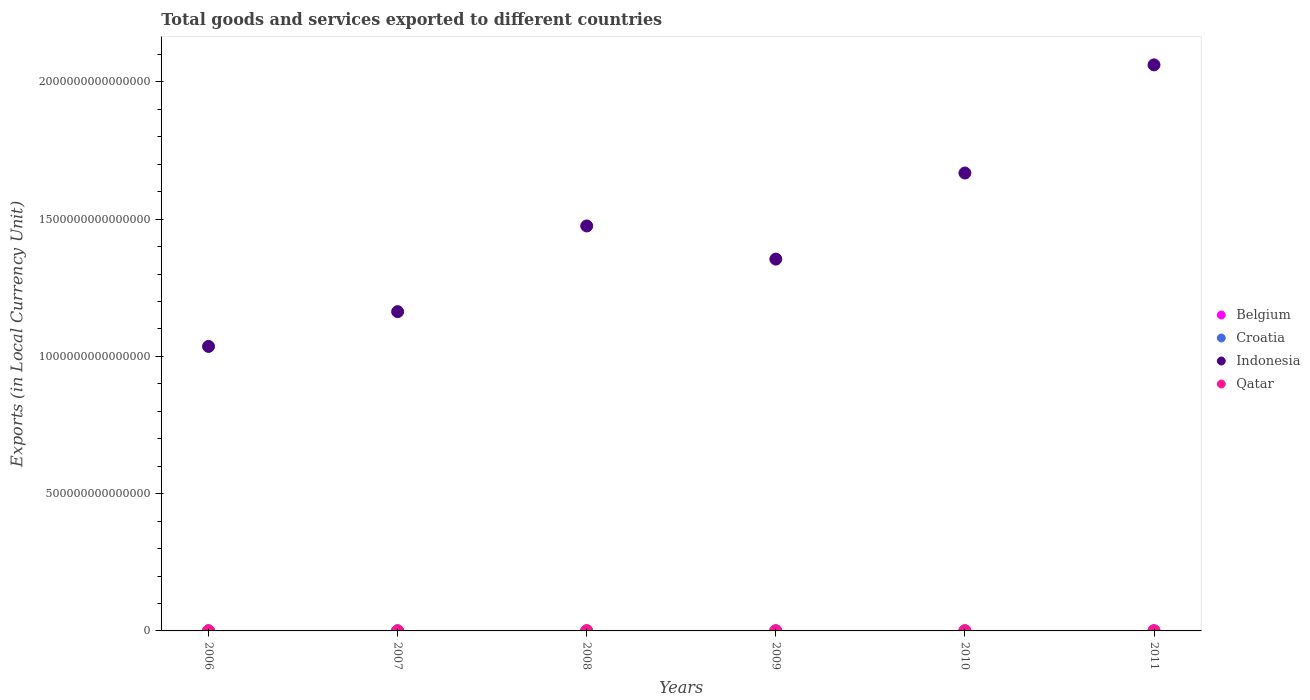What is the Amount of goods and services exports in Belgium in 2008?
Offer a terse response. 2.82e+11. Across all years, what is the maximum Amount of goods and services exports in Indonesia?
Offer a very short reply. 2.06e+15. Across all years, what is the minimum Amount of goods and services exports in Croatia?
Give a very brief answer. 1.14e+11. What is the total Amount of goods and services exports in Croatia in the graph?
Give a very brief answer. 7.49e+11. What is the difference between the Amount of goods and services exports in Belgium in 2008 and that in 2011?
Keep it short and to the point. -2.73e+1. What is the difference between the Amount of goods and services exports in Croatia in 2011 and the Amount of goods and services exports in Indonesia in 2007?
Give a very brief answer. -1.16e+15. What is the average Amount of goods and services exports in Belgium per year?
Offer a very short reply. 2.71e+11. In the year 2011, what is the difference between the Amount of goods and services exports in Indonesia and Amount of goods and services exports in Belgium?
Provide a succinct answer. 2.06e+15. What is the ratio of the Amount of goods and services exports in Qatar in 2007 to that in 2011?
Your answer should be compact. 0.39. What is the difference between the highest and the second highest Amount of goods and services exports in Croatia?
Give a very brief answer. 6.04e+08. What is the difference between the highest and the lowest Amount of goods and services exports in Croatia?
Your answer should be compact. 2.01e+1. Is the sum of the Amount of goods and services exports in Indonesia in 2006 and 2011 greater than the maximum Amount of goods and services exports in Croatia across all years?
Make the answer very short. Yes. Is it the case that in every year, the sum of the Amount of goods and services exports in Croatia and Amount of goods and services exports in Qatar  is greater than the Amount of goods and services exports in Indonesia?
Provide a succinct answer. No. What is the difference between two consecutive major ticks on the Y-axis?
Provide a short and direct response. 5.00e+14. Are the values on the major ticks of Y-axis written in scientific E-notation?
Offer a terse response. No. Does the graph contain any zero values?
Provide a succinct answer. No. Does the graph contain grids?
Your answer should be compact. No. What is the title of the graph?
Offer a very short reply. Total goods and services exported to different countries. What is the label or title of the Y-axis?
Provide a succinct answer. Exports (in Local Currency Unit). What is the Exports (in Local Currency Unit) of Belgium in 2006?
Keep it short and to the point. 2.47e+11. What is the Exports (in Local Currency Unit) of Croatia in 2006?
Your answer should be very brief. 1.17e+11. What is the Exports (in Local Currency Unit) in Indonesia in 2006?
Provide a short and direct response. 1.04e+15. What is the Exports (in Local Currency Unit) in Qatar in 2006?
Give a very brief answer. 1.39e+11. What is the Exports (in Local Currency Unit) in Belgium in 2007?
Offer a terse response. 2.67e+11. What is the Exports (in Local Currency Unit) in Croatia in 2007?
Your response must be concise. 1.26e+11. What is the Exports (in Local Currency Unit) in Indonesia in 2007?
Offer a terse response. 1.16e+15. What is the Exports (in Local Currency Unit) of Qatar in 2007?
Keep it short and to the point. 1.75e+11. What is the Exports (in Local Currency Unit) of Belgium in 2008?
Make the answer very short. 2.82e+11. What is the Exports (in Local Currency Unit) of Croatia in 2008?
Your answer should be very brief. 1.34e+11. What is the Exports (in Local Currency Unit) of Indonesia in 2008?
Your answer should be compact. 1.48e+15. What is the Exports (in Local Currency Unit) in Qatar in 2008?
Give a very brief answer. 2.57e+11. What is the Exports (in Local Currency Unit) in Belgium in 2009?
Provide a succinct answer. 2.42e+11. What is the Exports (in Local Currency Unit) of Croatia in 2009?
Offer a terse response. 1.14e+11. What is the Exports (in Local Currency Unit) in Indonesia in 2009?
Your response must be concise. 1.35e+15. What is the Exports (in Local Currency Unit) of Qatar in 2009?
Provide a short and direct response. 1.82e+11. What is the Exports (in Local Currency Unit) of Belgium in 2010?
Ensure brevity in your answer.  2.79e+11. What is the Exports (in Local Currency Unit) in Croatia in 2010?
Ensure brevity in your answer.  1.24e+11. What is the Exports (in Local Currency Unit) in Indonesia in 2010?
Offer a terse response. 1.67e+15. What is the Exports (in Local Currency Unit) of Qatar in 2010?
Keep it short and to the point. 2.84e+11. What is the Exports (in Local Currency Unit) in Belgium in 2011?
Offer a very short reply. 3.09e+11. What is the Exports (in Local Currency Unit) of Croatia in 2011?
Make the answer very short. 1.34e+11. What is the Exports (in Local Currency Unit) of Indonesia in 2011?
Give a very brief answer. 2.06e+15. What is the Exports (in Local Currency Unit) of Qatar in 2011?
Provide a short and direct response. 4.43e+11. Across all years, what is the maximum Exports (in Local Currency Unit) of Belgium?
Your response must be concise. 3.09e+11. Across all years, what is the maximum Exports (in Local Currency Unit) of Croatia?
Ensure brevity in your answer.  1.34e+11. Across all years, what is the maximum Exports (in Local Currency Unit) of Indonesia?
Ensure brevity in your answer.  2.06e+15. Across all years, what is the maximum Exports (in Local Currency Unit) in Qatar?
Give a very brief answer. 4.43e+11. Across all years, what is the minimum Exports (in Local Currency Unit) in Belgium?
Make the answer very short. 2.42e+11. Across all years, what is the minimum Exports (in Local Currency Unit) in Croatia?
Your answer should be very brief. 1.14e+11. Across all years, what is the minimum Exports (in Local Currency Unit) in Indonesia?
Keep it short and to the point. 1.04e+15. Across all years, what is the minimum Exports (in Local Currency Unit) in Qatar?
Your answer should be compact. 1.39e+11. What is the total Exports (in Local Currency Unit) of Belgium in the graph?
Your answer should be compact. 1.63e+12. What is the total Exports (in Local Currency Unit) in Croatia in the graph?
Your answer should be compact. 7.49e+11. What is the total Exports (in Local Currency Unit) in Indonesia in the graph?
Your response must be concise. 8.76e+15. What is the total Exports (in Local Currency Unit) of Qatar in the graph?
Ensure brevity in your answer.  1.48e+12. What is the difference between the Exports (in Local Currency Unit) of Belgium in 2006 and that in 2007?
Your answer should be compact. -1.98e+1. What is the difference between the Exports (in Local Currency Unit) in Croatia in 2006 and that in 2007?
Your response must be concise. -8.92e+09. What is the difference between the Exports (in Local Currency Unit) of Indonesia in 2006 and that in 2007?
Your answer should be very brief. -1.27e+14. What is the difference between the Exports (in Local Currency Unit) of Qatar in 2006 and that in 2007?
Give a very brief answer. -3.57e+1. What is the difference between the Exports (in Local Currency Unit) of Belgium in 2006 and that in 2008?
Provide a succinct answer. -3.49e+1. What is the difference between the Exports (in Local Currency Unit) in Croatia in 2006 and that in 2008?
Your answer should be very brief. -1.70e+1. What is the difference between the Exports (in Local Currency Unit) of Indonesia in 2006 and that in 2008?
Offer a very short reply. -4.39e+14. What is the difference between the Exports (in Local Currency Unit) of Qatar in 2006 and that in 2008?
Keep it short and to the point. -1.18e+11. What is the difference between the Exports (in Local Currency Unit) of Belgium in 2006 and that in 2009?
Your response must be concise. 5.58e+09. What is the difference between the Exports (in Local Currency Unit) in Croatia in 2006 and that in 2009?
Keep it short and to the point. 2.52e+09. What is the difference between the Exports (in Local Currency Unit) of Indonesia in 2006 and that in 2009?
Your answer should be compact. -3.18e+14. What is the difference between the Exports (in Local Currency Unit) of Qatar in 2006 and that in 2009?
Give a very brief answer. -4.28e+1. What is the difference between the Exports (in Local Currency Unit) of Belgium in 2006 and that in 2010?
Keep it short and to the point. -3.18e+1. What is the difference between the Exports (in Local Currency Unit) in Croatia in 2006 and that in 2010?
Offer a terse response. -7.01e+09. What is the difference between the Exports (in Local Currency Unit) in Indonesia in 2006 and that in 2010?
Provide a succinct answer. -6.32e+14. What is the difference between the Exports (in Local Currency Unit) in Qatar in 2006 and that in 2010?
Your answer should be compact. -1.45e+11. What is the difference between the Exports (in Local Currency Unit) in Belgium in 2006 and that in 2011?
Give a very brief answer. -6.22e+1. What is the difference between the Exports (in Local Currency Unit) in Croatia in 2006 and that in 2011?
Your answer should be very brief. -1.76e+1. What is the difference between the Exports (in Local Currency Unit) of Indonesia in 2006 and that in 2011?
Provide a succinct answer. -1.03e+15. What is the difference between the Exports (in Local Currency Unit) in Qatar in 2006 and that in 2011?
Offer a terse response. -3.04e+11. What is the difference between the Exports (in Local Currency Unit) of Belgium in 2007 and that in 2008?
Keep it short and to the point. -1.51e+1. What is the difference between the Exports (in Local Currency Unit) in Croatia in 2007 and that in 2008?
Provide a succinct answer. -8.08e+09. What is the difference between the Exports (in Local Currency Unit) of Indonesia in 2007 and that in 2008?
Give a very brief answer. -3.12e+14. What is the difference between the Exports (in Local Currency Unit) in Qatar in 2007 and that in 2008?
Offer a very short reply. -8.26e+1. What is the difference between the Exports (in Local Currency Unit) in Belgium in 2007 and that in 2009?
Ensure brevity in your answer.  2.54e+1. What is the difference between the Exports (in Local Currency Unit) of Croatia in 2007 and that in 2009?
Offer a very short reply. 1.14e+1. What is the difference between the Exports (in Local Currency Unit) in Indonesia in 2007 and that in 2009?
Give a very brief answer. -1.91e+14. What is the difference between the Exports (in Local Currency Unit) of Qatar in 2007 and that in 2009?
Your answer should be compact. -7.14e+09. What is the difference between the Exports (in Local Currency Unit) of Belgium in 2007 and that in 2010?
Make the answer very short. -1.20e+1. What is the difference between the Exports (in Local Currency Unit) of Croatia in 2007 and that in 2010?
Ensure brevity in your answer.  1.91e+09. What is the difference between the Exports (in Local Currency Unit) in Indonesia in 2007 and that in 2010?
Your answer should be very brief. -5.05e+14. What is the difference between the Exports (in Local Currency Unit) of Qatar in 2007 and that in 2010?
Provide a succinct answer. -1.09e+11. What is the difference between the Exports (in Local Currency Unit) in Belgium in 2007 and that in 2011?
Your response must be concise. -4.24e+1. What is the difference between the Exports (in Local Currency Unit) of Croatia in 2007 and that in 2011?
Keep it short and to the point. -8.68e+09. What is the difference between the Exports (in Local Currency Unit) of Indonesia in 2007 and that in 2011?
Your response must be concise. -8.99e+14. What is the difference between the Exports (in Local Currency Unit) in Qatar in 2007 and that in 2011?
Provide a succinct answer. -2.69e+11. What is the difference between the Exports (in Local Currency Unit) in Belgium in 2008 and that in 2009?
Provide a succinct answer. 4.04e+1. What is the difference between the Exports (in Local Currency Unit) in Croatia in 2008 and that in 2009?
Offer a very short reply. 1.95e+1. What is the difference between the Exports (in Local Currency Unit) of Indonesia in 2008 and that in 2009?
Offer a terse response. 1.21e+14. What is the difference between the Exports (in Local Currency Unit) of Qatar in 2008 and that in 2009?
Your answer should be very brief. 7.54e+1. What is the difference between the Exports (in Local Currency Unit) of Belgium in 2008 and that in 2010?
Keep it short and to the point. 3.06e+09. What is the difference between the Exports (in Local Currency Unit) of Croatia in 2008 and that in 2010?
Offer a very short reply. 9.99e+09. What is the difference between the Exports (in Local Currency Unit) in Indonesia in 2008 and that in 2010?
Your answer should be very brief. -1.93e+14. What is the difference between the Exports (in Local Currency Unit) in Qatar in 2008 and that in 2010?
Ensure brevity in your answer.  -2.64e+1. What is the difference between the Exports (in Local Currency Unit) in Belgium in 2008 and that in 2011?
Keep it short and to the point. -2.73e+1. What is the difference between the Exports (in Local Currency Unit) in Croatia in 2008 and that in 2011?
Give a very brief answer. -6.04e+08. What is the difference between the Exports (in Local Currency Unit) of Indonesia in 2008 and that in 2011?
Ensure brevity in your answer.  -5.87e+14. What is the difference between the Exports (in Local Currency Unit) in Qatar in 2008 and that in 2011?
Provide a succinct answer. -1.86e+11. What is the difference between the Exports (in Local Currency Unit) in Belgium in 2009 and that in 2010?
Ensure brevity in your answer.  -3.74e+1. What is the difference between the Exports (in Local Currency Unit) of Croatia in 2009 and that in 2010?
Make the answer very short. -9.53e+09. What is the difference between the Exports (in Local Currency Unit) in Indonesia in 2009 and that in 2010?
Offer a terse response. -3.14e+14. What is the difference between the Exports (in Local Currency Unit) in Qatar in 2009 and that in 2010?
Your answer should be compact. -1.02e+11. What is the difference between the Exports (in Local Currency Unit) in Belgium in 2009 and that in 2011?
Make the answer very short. -6.77e+1. What is the difference between the Exports (in Local Currency Unit) in Croatia in 2009 and that in 2011?
Offer a very short reply. -2.01e+1. What is the difference between the Exports (in Local Currency Unit) of Indonesia in 2009 and that in 2011?
Your response must be concise. -7.07e+14. What is the difference between the Exports (in Local Currency Unit) in Qatar in 2009 and that in 2011?
Ensure brevity in your answer.  -2.61e+11. What is the difference between the Exports (in Local Currency Unit) in Belgium in 2010 and that in 2011?
Your answer should be compact. -3.04e+1. What is the difference between the Exports (in Local Currency Unit) in Croatia in 2010 and that in 2011?
Provide a short and direct response. -1.06e+1. What is the difference between the Exports (in Local Currency Unit) in Indonesia in 2010 and that in 2011?
Your answer should be compact. -3.94e+14. What is the difference between the Exports (in Local Currency Unit) of Qatar in 2010 and that in 2011?
Your response must be concise. -1.60e+11. What is the difference between the Exports (in Local Currency Unit) of Belgium in 2006 and the Exports (in Local Currency Unit) of Croatia in 2007?
Offer a very short reply. 1.22e+11. What is the difference between the Exports (in Local Currency Unit) of Belgium in 2006 and the Exports (in Local Currency Unit) of Indonesia in 2007?
Your answer should be very brief. -1.16e+15. What is the difference between the Exports (in Local Currency Unit) of Belgium in 2006 and the Exports (in Local Currency Unit) of Qatar in 2007?
Make the answer very short. 7.24e+1. What is the difference between the Exports (in Local Currency Unit) in Croatia in 2006 and the Exports (in Local Currency Unit) in Indonesia in 2007?
Make the answer very short. -1.16e+15. What is the difference between the Exports (in Local Currency Unit) in Croatia in 2006 and the Exports (in Local Currency Unit) in Qatar in 2007?
Offer a terse response. -5.81e+1. What is the difference between the Exports (in Local Currency Unit) in Indonesia in 2006 and the Exports (in Local Currency Unit) in Qatar in 2007?
Your answer should be compact. 1.04e+15. What is the difference between the Exports (in Local Currency Unit) of Belgium in 2006 and the Exports (in Local Currency Unit) of Croatia in 2008?
Provide a succinct answer. 1.14e+11. What is the difference between the Exports (in Local Currency Unit) in Belgium in 2006 and the Exports (in Local Currency Unit) in Indonesia in 2008?
Make the answer very short. -1.47e+15. What is the difference between the Exports (in Local Currency Unit) in Belgium in 2006 and the Exports (in Local Currency Unit) in Qatar in 2008?
Offer a terse response. -1.01e+1. What is the difference between the Exports (in Local Currency Unit) in Croatia in 2006 and the Exports (in Local Currency Unit) in Indonesia in 2008?
Keep it short and to the point. -1.48e+15. What is the difference between the Exports (in Local Currency Unit) of Croatia in 2006 and the Exports (in Local Currency Unit) of Qatar in 2008?
Your answer should be compact. -1.41e+11. What is the difference between the Exports (in Local Currency Unit) of Indonesia in 2006 and the Exports (in Local Currency Unit) of Qatar in 2008?
Your answer should be compact. 1.04e+15. What is the difference between the Exports (in Local Currency Unit) in Belgium in 2006 and the Exports (in Local Currency Unit) in Croatia in 2009?
Offer a terse response. 1.33e+11. What is the difference between the Exports (in Local Currency Unit) of Belgium in 2006 and the Exports (in Local Currency Unit) of Indonesia in 2009?
Offer a terse response. -1.35e+15. What is the difference between the Exports (in Local Currency Unit) of Belgium in 2006 and the Exports (in Local Currency Unit) of Qatar in 2009?
Offer a very short reply. 6.53e+1. What is the difference between the Exports (in Local Currency Unit) in Croatia in 2006 and the Exports (in Local Currency Unit) in Indonesia in 2009?
Your answer should be very brief. -1.35e+15. What is the difference between the Exports (in Local Currency Unit) in Croatia in 2006 and the Exports (in Local Currency Unit) in Qatar in 2009?
Provide a succinct answer. -6.52e+1. What is the difference between the Exports (in Local Currency Unit) of Indonesia in 2006 and the Exports (in Local Currency Unit) of Qatar in 2009?
Keep it short and to the point. 1.04e+15. What is the difference between the Exports (in Local Currency Unit) of Belgium in 2006 and the Exports (in Local Currency Unit) of Croatia in 2010?
Ensure brevity in your answer.  1.24e+11. What is the difference between the Exports (in Local Currency Unit) in Belgium in 2006 and the Exports (in Local Currency Unit) in Indonesia in 2010?
Give a very brief answer. -1.67e+15. What is the difference between the Exports (in Local Currency Unit) in Belgium in 2006 and the Exports (in Local Currency Unit) in Qatar in 2010?
Give a very brief answer. -3.65e+1. What is the difference between the Exports (in Local Currency Unit) in Croatia in 2006 and the Exports (in Local Currency Unit) in Indonesia in 2010?
Your answer should be very brief. -1.67e+15. What is the difference between the Exports (in Local Currency Unit) in Croatia in 2006 and the Exports (in Local Currency Unit) in Qatar in 2010?
Keep it short and to the point. -1.67e+11. What is the difference between the Exports (in Local Currency Unit) in Indonesia in 2006 and the Exports (in Local Currency Unit) in Qatar in 2010?
Ensure brevity in your answer.  1.04e+15. What is the difference between the Exports (in Local Currency Unit) in Belgium in 2006 and the Exports (in Local Currency Unit) in Croatia in 2011?
Make the answer very short. 1.13e+11. What is the difference between the Exports (in Local Currency Unit) of Belgium in 2006 and the Exports (in Local Currency Unit) of Indonesia in 2011?
Your response must be concise. -2.06e+15. What is the difference between the Exports (in Local Currency Unit) in Belgium in 2006 and the Exports (in Local Currency Unit) in Qatar in 2011?
Give a very brief answer. -1.96e+11. What is the difference between the Exports (in Local Currency Unit) of Croatia in 2006 and the Exports (in Local Currency Unit) of Indonesia in 2011?
Your answer should be compact. -2.06e+15. What is the difference between the Exports (in Local Currency Unit) in Croatia in 2006 and the Exports (in Local Currency Unit) in Qatar in 2011?
Provide a succinct answer. -3.27e+11. What is the difference between the Exports (in Local Currency Unit) in Indonesia in 2006 and the Exports (in Local Currency Unit) in Qatar in 2011?
Make the answer very short. 1.04e+15. What is the difference between the Exports (in Local Currency Unit) in Belgium in 2007 and the Exports (in Local Currency Unit) in Croatia in 2008?
Provide a succinct answer. 1.33e+11. What is the difference between the Exports (in Local Currency Unit) of Belgium in 2007 and the Exports (in Local Currency Unit) of Indonesia in 2008?
Your response must be concise. -1.47e+15. What is the difference between the Exports (in Local Currency Unit) in Belgium in 2007 and the Exports (in Local Currency Unit) in Qatar in 2008?
Your answer should be very brief. 9.66e+09. What is the difference between the Exports (in Local Currency Unit) in Croatia in 2007 and the Exports (in Local Currency Unit) in Indonesia in 2008?
Provide a succinct answer. -1.47e+15. What is the difference between the Exports (in Local Currency Unit) in Croatia in 2007 and the Exports (in Local Currency Unit) in Qatar in 2008?
Make the answer very short. -1.32e+11. What is the difference between the Exports (in Local Currency Unit) of Indonesia in 2007 and the Exports (in Local Currency Unit) of Qatar in 2008?
Give a very brief answer. 1.16e+15. What is the difference between the Exports (in Local Currency Unit) in Belgium in 2007 and the Exports (in Local Currency Unit) in Croatia in 2009?
Offer a terse response. 1.53e+11. What is the difference between the Exports (in Local Currency Unit) of Belgium in 2007 and the Exports (in Local Currency Unit) of Indonesia in 2009?
Your answer should be compact. -1.35e+15. What is the difference between the Exports (in Local Currency Unit) of Belgium in 2007 and the Exports (in Local Currency Unit) of Qatar in 2009?
Offer a very short reply. 8.51e+1. What is the difference between the Exports (in Local Currency Unit) in Croatia in 2007 and the Exports (in Local Currency Unit) in Indonesia in 2009?
Your answer should be compact. -1.35e+15. What is the difference between the Exports (in Local Currency Unit) in Croatia in 2007 and the Exports (in Local Currency Unit) in Qatar in 2009?
Keep it short and to the point. -5.63e+1. What is the difference between the Exports (in Local Currency Unit) of Indonesia in 2007 and the Exports (in Local Currency Unit) of Qatar in 2009?
Your answer should be very brief. 1.16e+15. What is the difference between the Exports (in Local Currency Unit) in Belgium in 2007 and the Exports (in Local Currency Unit) in Croatia in 2010?
Offer a very short reply. 1.43e+11. What is the difference between the Exports (in Local Currency Unit) in Belgium in 2007 and the Exports (in Local Currency Unit) in Indonesia in 2010?
Your response must be concise. -1.67e+15. What is the difference between the Exports (in Local Currency Unit) of Belgium in 2007 and the Exports (in Local Currency Unit) of Qatar in 2010?
Provide a succinct answer. -1.67e+1. What is the difference between the Exports (in Local Currency Unit) of Croatia in 2007 and the Exports (in Local Currency Unit) of Indonesia in 2010?
Keep it short and to the point. -1.67e+15. What is the difference between the Exports (in Local Currency Unit) of Croatia in 2007 and the Exports (in Local Currency Unit) of Qatar in 2010?
Offer a terse response. -1.58e+11. What is the difference between the Exports (in Local Currency Unit) in Indonesia in 2007 and the Exports (in Local Currency Unit) in Qatar in 2010?
Make the answer very short. 1.16e+15. What is the difference between the Exports (in Local Currency Unit) of Belgium in 2007 and the Exports (in Local Currency Unit) of Croatia in 2011?
Provide a succinct answer. 1.33e+11. What is the difference between the Exports (in Local Currency Unit) in Belgium in 2007 and the Exports (in Local Currency Unit) in Indonesia in 2011?
Make the answer very short. -2.06e+15. What is the difference between the Exports (in Local Currency Unit) in Belgium in 2007 and the Exports (in Local Currency Unit) in Qatar in 2011?
Provide a short and direct response. -1.76e+11. What is the difference between the Exports (in Local Currency Unit) of Croatia in 2007 and the Exports (in Local Currency Unit) of Indonesia in 2011?
Make the answer very short. -2.06e+15. What is the difference between the Exports (in Local Currency Unit) in Croatia in 2007 and the Exports (in Local Currency Unit) in Qatar in 2011?
Keep it short and to the point. -3.18e+11. What is the difference between the Exports (in Local Currency Unit) in Indonesia in 2007 and the Exports (in Local Currency Unit) in Qatar in 2011?
Give a very brief answer. 1.16e+15. What is the difference between the Exports (in Local Currency Unit) in Belgium in 2008 and the Exports (in Local Currency Unit) in Croatia in 2009?
Provide a succinct answer. 1.68e+11. What is the difference between the Exports (in Local Currency Unit) in Belgium in 2008 and the Exports (in Local Currency Unit) in Indonesia in 2009?
Ensure brevity in your answer.  -1.35e+15. What is the difference between the Exports (in Local Currency Unit) of Belgium in 2008 and the Exports (in Local Currency Unit) of Qatar in 2009?
Your answer should be compact. 1.00e+11. What is the difference between the Exports (in Local Currency Unit) in Croatia in 2008 and the Exports (in Local Currency Unit) in Indonesia in 2009?
Provide a short and direct response. -1.35e+15. What is the difference between the Exports (in Local Currency Unit) in Croatia in 2008 and the Exports (in Local Currency Unit) in Qatar in 2009?
Your answer should be very brief. -4.83e+1. What is the difference between the Exports (in Local Currency Unit) of Indonesia in 2008 and the Exports (in Local Currency Unit) of Qatar in 2009?
Offer a very short reply. 1.47e+15. What is the difference between the Exports (in Local Currency Unit) of Belgium in 2008 and the Exports (in Local Currency Unit) of Croatia in 2010?
Provide a succinct answer. 1.58e+11. What is the difference between the Exports (in Local Currency Unit) in Belgium in 2008 and the Exports (in Local Currency Unit) in Indonesia in 2010?
Ensure brevity in your answer.  -1.67e+15. What is the difference between the Exports (in Local Currency Unit) of Belgium in 2008 and the Exports (in Local Currency Unit) of Qatar in 2010?
Ensure brevity in your answer.  -1.66e+09. What is the difference between the Exports (in Local Currency Unit) in Croatia in 2008 and the Exports (in Local Currency Unit) in Indonesia in 2010?
Your response must be concise. -1.67e+15. What is the difference between the Exports (in Local Currency Unit) of Croatia in 2008 and the Exports (in Local Currency Unit) of Qatar in 2010?
Your answer should be compact. -1.50e+11. What is the difference between the Exports (in Local Currency Unit) in Indonesia in 2008 and the Exports (in Local Currency Unit) in Qatar in 2010?
Give a very brief answer. 1.47e+15. What is the difference between the Exports (in Local Currency Unit) of Belgium in 2008 and the Exports (in Local Currency Unit) of Croatia in 2011?
Make the answer very short. 1.48e+11. What is the difference between the Exports (in Local Currency Unit) of Belgium in 2008 and the Exports (in Local Currency Unit) of Indonesia in 2011?
Your response must be concise. -2.06e+15. What is the difference between the Exports (in Local Currency Unit) in Belgium in 2008 and the Exports (in Local Currency Unit) in Qatar in 2011?
Your answer should be very brief. -1.61e+11. What is the difference between the Exports (in Local Currency Unit) of Croatia in 2008 and the Exports (in Local Currency Unit) of Indonesia in 2011?
Offer a very short reply. -2.06e+15. What is the difference between the Exports (in Local Currency Unit) of Croatia in 2008 and the Exports (in Local Currency Unit) of Qatar in 2011?
Make the answer very short. -3.10e+11. What is the difference between the Exports (in Local Currency Unit) of Indonesia in 2008 and the Exports (in Local Currency Unit) of Qatar in 2011?
Your response must be concise. 1.47e+15. What is the difference between the Exports (in Local Currency Unit) in Belgium in 2009 and the Exports (in Local Currency Unit) in Croatia in 2010?
Ensure brevity in your answer.  1.18e+11. What is the difference between the Exports (in Local Currency Unit) of Belgium in 2009 and the Exports (in Local Currency Unit) of Indonesia in 2010?
Offer a terse response. -1.67e+15. What is the difference between the Exports (in Local Currency Unit) of Belgium in 2009 and the Exports (in Local Currency Unit) of Qatar in 2010?
Keep it short and to the point. -4.21e+1. What is the difference between the Exports (in Local Currency Unit) of Croatia in 2009 and the Exports (in Local Currency Unit) of Indonesia in 2010?
Your response must be concise. -1.67e+15. What is the difference between the Exports (in Local Currency Unit) in Croatia in 2009 and the Exports (in Local Currency Unit) in Qatar in 2010?
Provide a short and direct response. -1.70e+11. What is the difference between the Exports (in Local Currency Unit) of Indonesia in 2009 and the Exports (in Local Currency Unit) of Qatar in 2010?
Keep it short and to the point. 1.35e+15. What is the difference between the Exports (in Local Currency Unit) in Belgium in 2009 and the Exports (in Local Currency Unit) in Croatia in 2011?
Provide a succinct answer. 1.07e+11. What is the difference between the Exports (in Local Currency Unit) in Belgium in 2009 and the Exports (in Local Currency Unit) in Indonesia in 2011?
Provide a short and direct response. -2.06e+15. What is the difference between the Exports (in Local Currency Unit) of Belgium in 2009 and the Exports (in Local Currency Unit) of Qatar in 2011?
Your answer should be very brief. -2.02e+11. What is the difference between the Exports (in Local Currency Unit) in Croatia in 2009 and the Exports (in Local Currency Unit) in Indonesia in 2011?
Offer a very short reply. -2.06e+15. What is the difference between the Exports (in Local Currency Unit) of Croatia in 2009 and the Exports (in Local Currency Unit) of Qatar in 2011?
Offer a terse response. -3.29e+11. What is the difference between the Exports (in Local Currency Unit) of Indonesia in 2009 and the Exports (in Local Currency Unit) of Qatar in 2011?
Provide a short and direct response. 1.35e+15. What is the difference between the Exports (in Local Currency Unit) in Belgium in 2010 and the Exports (in Local Currency Unit) in Croatia in 2011?
Your answer should be compact. 1.45e+11. What is the difference between the Exports (in Local Currency Unit) in Belgium in 2010 and the Exports (in Local Currency Unit) in Indonesia in 2011?
Keep it short and to the point. -2.06e+15. What is the difference between the Exports (in Local Currency Unit) of Belgium in 2010 and the Exports (in Local Currency Unit) of Qatar in 2011?
Make the answer very short. -1.64e+11. What is the difference between the Exports (in Local Currency Unit) in Croatia in 2010 and the Exports (in Local Currency Unit) in Indonesia in 2011?
Give a very brief answer. -2.06e+15. What is the difference between the Exports (in Local Currency Unit) of Croatia in 2010 and the Exports (in Local Currency Unit) of Qatar in 2011?
Keep it short and to the point. -3.20e+11. What is the difference between the Exports (in Local Currency Unit) of Indonesia in 2010 and the Exports (in Local Currency Unit) of Qatar in 2011?
Provide a short and direct response. 1.67e+15. What is the average Exports (in Local Currency Unit) in Belgium per year?
Your answer should be compact. 2.71e+11. What is the average Exports (in Local Currency Unit) in Croatia per year?
Your answer should be very brief. 1.25e+11. What is the average Exports (in Local Currency Unit) in Indonesia per year?
Provide a short and direct response. 1.46e+15. What is the average Exports (in Local Currency Unit) of Qatar per year?
Offer a terse response. 2.47e+11. In the year 2006, what is the difference between the Exports (in Local Currency Unit) of Belgium and Exports (in Local Currency Unit) of Croatia?
Provide a succinct answer. 1.31e+11. In the year 2006, what is the difference between the Exports (in Local Currency Unit) in Belgium and Exports (in Local Currency Unit) in Indonesia?
Your answer should be very brief. -1.04e+15. In the year 2006, what is the difference between the Exports (in Local Currency Unit) of Belgium and Exports (in Local Currency Unit) of Qatar?
Make the answer very short. 1.08e+11. In the year 2006, what is the difference between the Exports (in Local Currency Unit) in Croatia and Exports (in Local Currency Unit) in Indonesia?
Make the answer very short. -1.04e+15. In the year 2006, what is the difference between the Exports (in Local Currency Unit) in Croatia and Exports (in Local Currency Unit) in Qatar?
Offer a terse response. -2.24e+1. In the year 2006, what is the difference between the Exports (in Local Currency Unit) in Indonesia and Exports (in Local Currency Unit) in Qatar?
Offer a terse response. 1.04e+15. In the year 2007, what is the difference between the Exports (in Local Currency Unit) in Belgium and Exports (in Local Currency Unit) in Croatia?
Your answer should be compact. 1.41e+11. In the year 2007, what is the difference between the Exports (in Local Currency Unit) of Belgium and Exports (in Local Currency Unit) of Indonesia?
Make the answer very short. -1.16e+15. In the year 2007, what is the difference between the Exports (in Local Currency Unit) in Belgium and Exports (in Local Currency Unit) in Qatar?
Your answer should be very brief. 9.22e+1. In the year 2007, what is the difference between the Exports (in Local Currency Unit) of Croatia and Exports (in Local Currency Unit) of Indonesia?
Keep it short and to the point. -1.16e+15. In the year 2007, what is the difference between the Exports (in Local Currency Unit) of Croatia and Exports (in Local Currency Unit) of Qatar?
Offer a terse response. -4.92e+1. In the year 2007, what is the difference between the Exports (in Local Currency Unit) of Indonesia and Exports (in Local Currency Unit) of Qatar?
Your response must be concise. 1.16e+15. In the year 2008, what is the difference between the Exports (in Local Currency Unit) of Belgium and Exports (in Local Currency Unit) of Croatia?
Give a very brief answer. 1.48e+11. In the year 2008, what is the difference between the Exports (in Local Currency Unit) of Belgium and Exports (in Local Currency Unit) of Indonesia?
Provide a succinct answer. -1.47e+15. In the year 2008, what is the difference between the Exports (in Local Currency Unit) in Belgium and Exports (in Local Currency Unit) in Qatar?
Provide a succinct answer. 2.47e+1. In the year 2008, what is the difference between the Exports (in Local Currency Unit) in Croatia and Exports (in Local Currency Unit) in Indonesia?
Your response must be concise. -1.47e+15. In the year 2008, what is the difference between the Exports (in Local Currency Unit) of Croatia and Exports (in Local Currency Unit) of Qatar?
Provide a succinct answer. -1.24e+11. In the year 2008, what is the difference between the Exports (in Local Currency Unit) in Indonesia and Exports (in Local Currency Unit) in Qatar?
Make the answer very short. 1.47e+15. In the year 2009, what is the difference between the Exports (in Local Currency Unit) of Belgium and Exports (in Local Currency Unit) of Croatia?
Offer a terse response. 1.27e+11. In the year 2009, what is the difference between the Exports (in Local Currency Unit) in Belgium and Exports (in Local Currency Unit) in Indonesia?
Offer a very short reply. -1.35e+15. In the year 2009, what is the difference between the Exports (in Local Currency Unit) of Belgium and Exports (in Local Currency Unit) of Qatar?
Provide a short and direct response. 5.97e+1. In the year 2009, what is the difference between the Exports (in Local Currency Unit) of Croatia and Exports (in Local Currency Unit) of Indonesia?
Ensure brevity in your answer.  -1.35e+15. In the year 2009, what is the difference between the Exports (in Local Currency Unit) in Croatia and Exports (in Local Currency Unit) in Qatar?
Give a very brief answer. -6.78e+1. In the year 2009, what is the difference between the Exports (in Local Currency Unit) of Indonesia and Exports (in Local Currency Unit) of Qatar?
Provide a short and direct response. 1.35e+15. In the year 2010, what is the difference between the Exports (in Local Currency Unit) of Belgium and Exports (in Local Currency Unit) of Croatia?
Ensure brevity in your answer.  1.55e+11. In the year 2010, what is the difference between the Exports (in Local Currency Unit) in Belgium and Exports (in Local Currency Unit) in Indonesia?
Provide a short and direct response. -1.67e+15. In the year 2010, what is the difference between the Exports (in Local Currency Unit) in Belgium and Exports (in Local Currency Unit) in Qatar?
Your answer should be very brief. -4.72e+09. In the year 2010, what is the difference between the Exports (in Local Currency Unit) in Croatia and Exports (in Local Currency Unit) in Indonesia?
Your answer should be very brief. -1.67e+15. In the year 2010, what is the difference between the Exports (in Local Currency Unit) of Croatia and Exports (in Local Currency Unit) of Qatar?
Keep it short and to the point. -1.60e+11. In the year 2010, what is the difference between the Exports (in Local Currency Unit) in Indonesia and Exports (in Local Currency Unit) in Qatar?
Ensure brevity in your answer.  1.67e+15. In the year 2011, what is the difference between the Exports (in Local Currency Unit) in Belgium and Exports (in Local Currency Unit) in Croatia?
Give a very brief answer. 1.75e+11. In the year 2011, what is the difference between the Exports (in Local Currency Unit) in Belgium and Exports (in Local Currency Unit) in Indonesia?
Provide a short and direct response. -2.06e+15. In the year 2011, what is the difference between the Exports (in Local Currency Unit) in Belgium and Exports (in Local Currency Unit) in Qatar?
Your response must be concise. -1.34e+11. In the year 2011, what is the difference between the Exports (in Local Currency Unit) of Croatia and Exports (in Local Currency Unit) of Indonesia?
Provide a succinct answer. -2.06e+15. In the year 2011, what is the difference between the Exports (in Local Currency Unit) in Croatia and Exports (in Local Currency Unit) in Qatar?
Your answer should be very brief. -3.09e+11. In the year 2011, what is the difference between the Exports (in Local Currency Unit) in Indonesia and Exports (in Local Currency Unit) in Qatar?
Keep it short and to the point. 2.06e+15. What is the ratio of the Exports (in Local Currency Unit) in Belgium in 2006 to that in 2007?
Provide a short and direct response. 0.93. What is the ratio of the Exports (in Local Currency Unit) in Croatia in 2006 to that in 2007?
Offer a very short reply. 0.93. What is the ratio of the Exports (in Local Currency Unit) of Indonesia in 2006 to that in 2007?
Your answer should be very brief. 0.89. What is the ratio of the Exports (in Local Currency Unit) in Qatar in 2006 to that in 2007?
Offer a terse response. 0.8. What is the ratio of the Exports (in Local Currency Unit) in Belgium in 2006 to that in 2008?
Keep it short and to the point. 0.88. What is the ratio of the Exports (in Local Currency Unit) of Croatia in 2006 to that in 2008?
Ensure brevity in your answer.  0.87. What is the ratio of the Exports (in Local Currency Unit) in Indonesia in 2006 to that in 2008?
Your answer should be compact. 0.7. What is the ratio of the Exports (in Local Currency Unit) of Qatar in 2006 to that in 2008?
Your answer should be compact. 0.54. What is the ratio of the Exports (in Local Currency Unit) in Belgium in 2006 to that in 2009?
Your answer should be compact. 1.02. What is the ratio of the Exports (in Local Currency Unit) of Croatia in 2006 to that in 2009?
Give a very brief answer. 1.02. What is the ratio of the Exports (in Local Currency Unit) in Indonesia in 2006 to that in 2009?
Offer a terse response. 0.77. What is the ratio of the Exports (in Local Currency Unit) in Qatar in 2006 to that in 2009?
Provide a succinct answer. 0.76. What is the ratio of the Exports (in Local Currency Unit) in Belgium in 2006 to that in 2010?
Keep it short and to the point. 0.89. What is the ratio of the Exports (in Local Currency Unit) of Croatia in 2006 to that in 2010?
Give a very brief answer. 0.94. What is the ratio of the Exports (in Local Currency Unit) of Indonesia in 2006 to that in 2010?
Ensure brevity in your answer.  0.62. What is the ratio of the Exports (in Local Currency Unit) of Qatar in 2006 to that in 2010?
Your answer should be compact. 0.49. What is the ratio of the Exports (in Local Currency Unit) in Belgium in 2006 to that in 2011?
Give a very brief answer. 0.8. What is the ratio of the Exports (in Local Currency Unit) in Croatia in 2006 to that in 2011?
Offer a very short reply. 0.87. What is the ratio of the Exports (in Local Currency Unit) in Indonesia in 2006 to that in 2011?
Your answer should be very brief. 0.5. What is the ratio of the Exports (in Local Currency Unit) of Qatar in 2006 to that in 2011?
Ensure brevity in your answer.  0.31. What is the ratio of the Exports (in Local Currency Unit) in Belgium in 2007 to that in 2008?
Give a very brief answer. 0.95. What is the ratio of the Exports (in Local Currency Unit) of Croatia in 2007 to that in 2008?
Give a very brief answer. 0.94. What is the ratio of the Exports (in Local Currency Unit) in Indonesia in 2007 to that in 2008?
Give a very brief answer. 0.79. What is the ratio of the Exports (in Local Currency Unit) of Qatar in 2007 to that in 2008?
Give a very brief answer. 0.68. What is the ratio of the Exports (in Local Currency Unit) of Belgium in 2007 to that in 2009?
Your response must be concise. 1.1. What is the ratio of the Exports (in Local Currency Unit) in Croatia in 2007 to that in 2009?
Offer a very short reply. 1.1. What is the ratio of the Exports (in Local Currency Unit) in Indonesia in 2007 to that in 2009?
Your response must be concise. 0.86. What is the ratio of the Exports (in Local Currency Unit) in Qatar in 2007 to that in 2009?
Offer a very short reply. 0.96. What is the ratio of the Exports (in Local Currency Unit) in Croatia in 2007 to that in 2010?
Provide a succinct answer. 1.02. What is the ratio of the Exports (in Local Currency Unit) of Indonesia in 2007 to that in 2010?
Provide a short and direct response. 0.7. What is the ratio of the Exports (in Local Currency Unit) of Qatar in 2007 to that in 2010?
Your answer should be compact. 0.62. What is the ratio of the Exports (in Local Currency Unit) in Belgium in 2007 to that in 2011?
Provide a short and direct response. 0.86. What is the ratio of the Exports (in Local Currency Unit) in Croatia in 2007 to that in 2011?
Your answer should be compact. 0.94. What is the ratio of the Exports (in Local Currency Unit) in Indonesia in 2007 to that in 2011?
Provide a short and direct response. 0.56. What is the ratio of the Exports (in Local Currency Unit) in Qatar in 2007 to that in 2011?
Provide a succinct answer. 0.39. What is the ratio of the Exports (in Local Currency Unit) of Belgium in 2008 to that in 2009?
Ensure brevity in your answer.  1.17. What is the ratio of the Exports (in Local Currency Unit) of Croatia in 2008 to that in 2009?
Provide a succinct answer. 1.17. What is the ratio of the Exports (in Local Currency Unit) of Indonesia in 2008 to that in 2009?
Provide a succinct answer. 1.09. What is the ratio of the Exports (in Local Currency Unit) of Qatar in 2008 to that in 2009?
Ensure brevity in your answer.  1.41. What is the ratio of the Exports (in Local Currency Unit) of Croatia in 2008 to that in 2010?
Offer a terse response. 1.08. What is the ratio of the Exports (in Local Currency Unit) of Indonesia in 2008 to that in 2010?
Provide a succinct answer. 0.88. What is the ratio of the Exports (in Local Currency Unit) of Qatar in 2008 to that in 2010?
Your response must be concise. 0.91. What is the ratio of the Exports (in Local Currency Unit) of Belgium in 2008 to that in 2011?
Ensure brevity in your answer.  0.91. What is the ratio of the Exports (in Local Currency Unit) of Indonesia in 2008 to that in 2011?
Your answer should be very brief. 0.72. What is the ratio of the Exports (in Local Currency Unit) of Qatar in 2008 to that in 2011?
Offer a terse response. 0.58. What is the ratio of the Exports (in Local Currency Unit) in Belgium in 2009 to that in 2010?
Your response must be concise. 0.87. What is the ratio of the Exports (in Local Currency Unit) of Croatia in 2009 to that in 2010?
Provide a succinct answer. 0.92. What is the ratio of the Exports (in Local Currency Unit) of Indonesia in 2009 to that in 2010?
Your answer should be very brief. 0.81. What is the ratio of the Exports (in Local Currency Unit) in Qatar in 2009 to that in 2010?
Offer a terse response. 0.64. What is the ratio of the Exports (in Local Currency Unit) in Belgium in 2009 to that in 2011?
Your answer should be very brief. 0.78. What is the ratio of the Exports (in Local Currency Unit) of Croatia in 2009 to that in 2011?
Offer a very short reply. 0.85. What is the ratio of the Exports (in Local Currency Unit) of Indonesia in 2009 to that in 2011?
Offer a very short reply. 0.66. What is the ratio of the Exports (in Local Currency Unit) of Qatar in 2009 to that in 2011?
Give a very brief answer. 0.41. What is the ratio of the Exports (in Local Currency Unit) of Belgium in 2010 to that in 2011?
Your response must be concise. 0.9. What is the ratio of the Exports (in Local Currency Unit) in Croatia in 2010 to that in 2011?
Your response must be concise. 0.92. What is the ratio of the Exports (in Local Currency Unit) of Indonesia in 2010 to that in 2011?
Your response must be concise. 0.81. What is the ratio of the Exports (in Local Currency Unit) in Qatar in 2010 to that in 2011?
Provide a short and direct response. 0.64. What is the difference between the highest and the second highest Exports (in Local Currency Unit) in Belgium?
Your response must be concise. 2.73e+1. What is the difference between the highest and the second highest Exports (in Local Currency Unit) in Croatia?
Keep it short and to the point. 6.04e+08. What is the difference between the highest and the second highest Exports (in Local Currency Unit) of Indonesia?
Provide a short and direct response. 3.94e+14. What is the difference between the highest and the second highest Exports (in Local Currency Unit) in Qatar?
Your answer should be compact. 1.60e+11. What is the difference between the highest and the lowest Exports (in Local Currency Unit) of Belgium?
Make the answer very short. 6.77e+1. What is the difference between the highest and the lowest Exports (in Local Currency Unit) of Croatia?
Your answer should be compact. 2.01e+1. What is the difference between the highest and the lowest Exports (in Local Currency Unit) in Indonesia?
Make the answer very short. 1.03e+15. What is the difference between the highest and the lowest Exports (in Local Currency Unit) in Qatar?
Your response must be concise. 3.04e+11. 